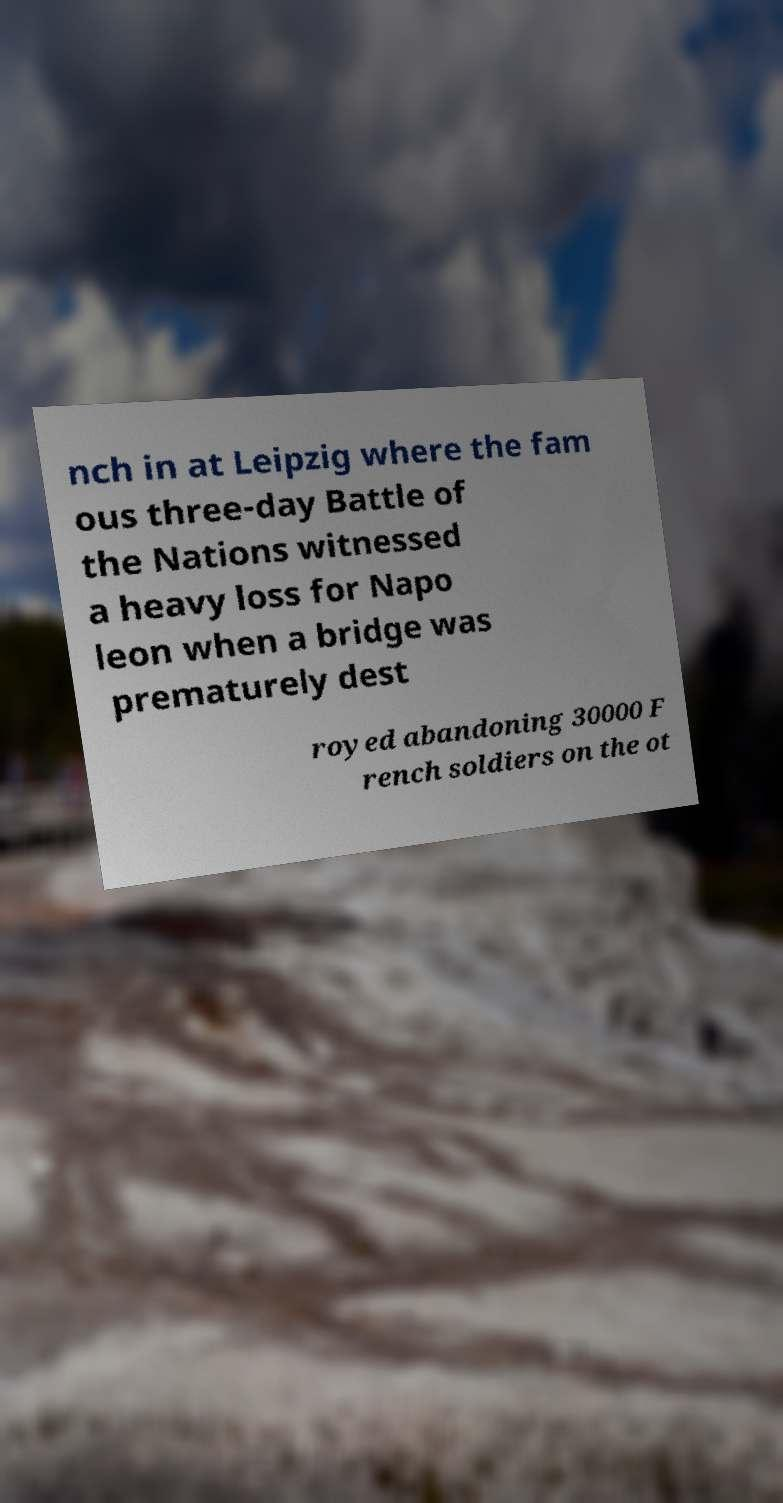Can you accurately transcribe the text from the provided image for me? nch in at Leipzig where the fam ous three-day Battle of the Nations witnessed a heavy loss for Napo leon when a bridge was prematurely dest royed abandoning 30000 F rench soldiers on the ot 